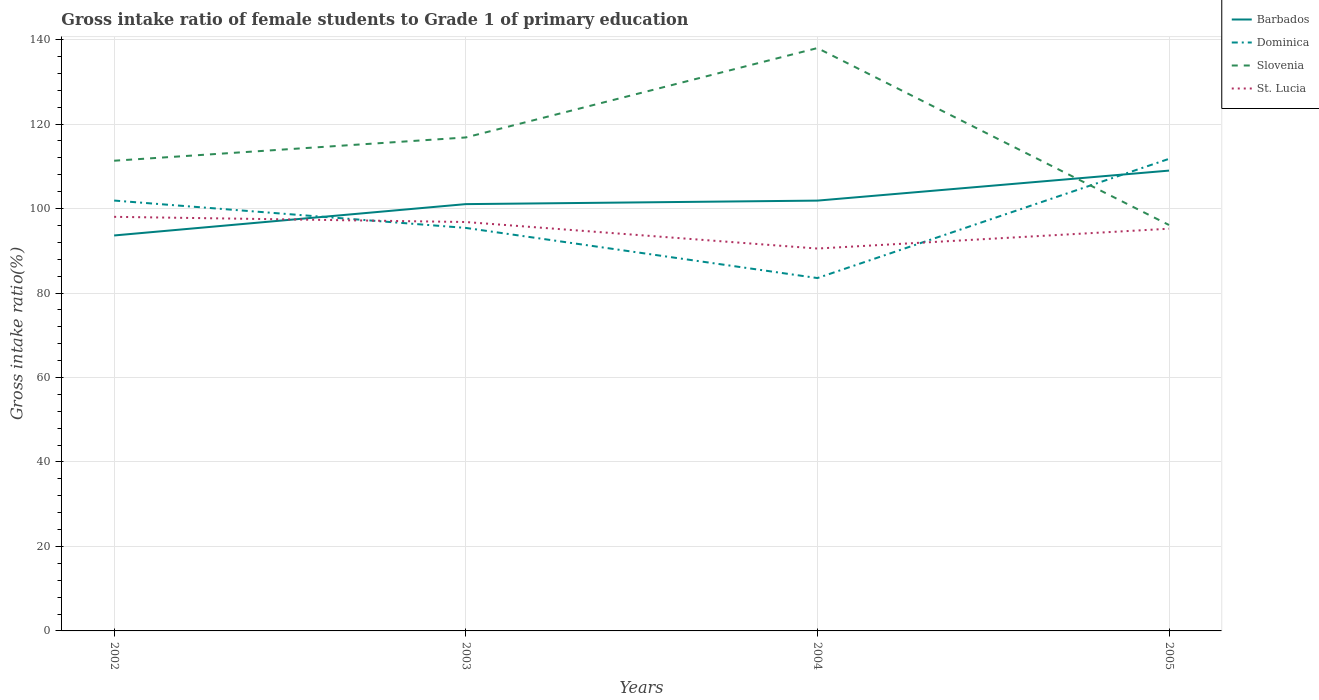How many different coloured lines are there?
Offer a terse response. 4. Does the line corresponding to Dominica intersect with the line corresponding to Slovenia?
Your response must be concise. Yes. Across all years, what is the maximum gross intake ratio in Dominica?
Offer a very short reply. 83.55. What is the total gross intake ratio in Slovenia in the graph?
Ensure brevity in your answer.  -5.51. What is the difference between the highest and the second highest gross intake ratio in Barbados?
Provide a succinct answer. 15.36. What is the difference between the highest and the lowest gross intake ratio in Slovenia?
Make the answer very short. 2. How many lines are there?
Offer a very short reply. 4. What is the difference between two consecutive major ticks on the Y-axis?
Give a very brief answer. 20. Are the values on the major ticks of Y-axis written in scientific E-notation?
Your response must be concise. No. Does the graph contain any zero values?
Keep it short and to the point. No. Does the graph contain grids?
Keep it short and to the point. Yes. What is the title of the graph?
Your answer should be compact. Gross intake ratio of female students to Grade 1 of primary education. What is the label or title of the X-axis?
Offer a terse response. Years. What is the label or title of the Y-axis?
Your response must be concise. Gross intake ratio(%). What is the Gross intake ratio(%) of Barbados in 2002?
Offer a very short reply. 93.63. What is the Gross intake ratio(%) of Dominica in 2002?
Provide a short and direct response. 101.9. What is the Gross intake ratio(%) of Slovenia in 2002?
Make the answer very short. 111.33. What is the Gross intake ratio(%) of St. Lucia in 2002?
Offer a very short reply. 98.05. What is the Gross intake ratio(%) of Barbados in 2003?
Your response must be concise. 101.05. What is the Gross intake ratio(%) of Dominica in 2003?
Offer a very short reply. 95.42. What is the Gross intake ratio(%) of Slovenia in 2003?
Offer a terse response. 116.84. What is the Gross intake ratio(%) of St. Lucia in 2003?
Give a very brief answer. 96.81. What is the Gross intake ratio(%) in Barbados in 2004?
Offer a terse response. 101.88. What is the Gross intake ratio(%) of Dominica in 2004?
Offer a terse response. 83.55. What is the Gross intake ratio(%) in Slovenia in 2004?
Your answer should be compact. 138. What is the Gross intake ratio(%) of St. Lucia in 2004?
Provide a short and direct response. 90.54. What is the Gross intake ratio(%) of Barbados in 2005?
Offer a very short reply. 108.99. What is the Gross intake ratio(%) of Dominica in 2005?
Offer a very short reply. 111.77. What is the Gross intake ratio(%) in Slovenia in 2005?
Offer a terse response. 96.11. What is the Gross intake ratio(%) of St. Lucia in 2005?
Make the answer very short. 95.23. Across all years, what is the maximum Gross intake ratio(%) of Barbados?
Ensure brevity in your answer.  108.99. Across all years, what is the maximum Gross intake ratio(%) of Dominica?
Provide a short and direct response. 111.77. Across all years, what is the maximum Gross intake ratio(%) of Slovenia?
Your answer should be very brief. 138. Across all years, what is the maximum Gross intake ratio(%) in St. Lucia?
Provide a succinct answer. 98.05. Across all years, what is the minimum Gross intake ratio(%) in Barbados?
Provide a succinct answer. 93.63. Across all years, what is the minimum Gross intake ratio(%) of Dominica?
Provide a succinct answer. 83.55. Across all years, what is the minimum Gross intake ratio(%) in Slovenia?
Provide a short and direct response. 96.11. Across all years, what is the minimum Gross intake ratio(%) of St. Lucia?
Provide a succinct answer. 90.54. What is the total Gross intake ratio(%) in Barbados in the graph?
Provide a succinct answer. 405.56. What is the total Gross intake ratio(%) of Dominica in the graph?
Provide a short and direct response. 392.64. What is the total Gross intake ratio(%) of Slovenia in the graph?
Provide a succinct answer. 462.28. What is the total Gross intake ratio(%) of St. Lucia in the graph?
Your response must be concise. 380.63. What is the difference between the Gross intake ratio(%) of Barbados in 2002 and that in 2003?
Make the answer very short. -7.42. What is the difference between the Gross intake ratio(%) of Dominica in 2002 and that in 2003?
Your response must be concise. 6.48. What is the difference between the Gross intake ratio(%) of Slovenia in 2002 and that in 2003?
Give a very brief answer. -5.51. What is the difference between the Gross intake ratio(%) in St. Lucia in 2002 and that in 2003?
Provide a succinct answer. 1.23. What is the difference between the Gross intake ratio(%) in Barbados in 2002 and that in 2004?
Provide a short and direct response. -8.25. What is the difference between the Gross intake ratio(%) of Dominica in 2002 and that in 2004?
Provide a succinct answer. 18.35. What is the difference between the Gross intake ratio(%) of Slovenia in 2002 and that in 2004?
Provide a short and direct response. -26.67. What is the difference between the Gross intake ratio(%) in St. Lucia in 2002 and that in 2004?
Your answer should be very brief. 7.51. What is the difference between the Gross intake ratio(%) in Barbados in 2002 and that in 2005?
Make the answer very short. -15.36. What is the difference between the Gross intake ratio(%) of Dominica in 2002 and that in 2005?
Your answer should be very brief. -9.88. What is the difference between the Gross intake ratio(%) in Slovenia in 2002 and that in 2005?
Make the answer very short. 15.22. What is the difference between the Gross intake ratio(%) in St. Lucia in 2002 and that in 2005?
Offer a terse response. 2.81. What is the difference between the Gross intake ratio(%) of Barbados in 2003 and that in 2004?
Make the answer very short. -0.83. What is the difference between the Gross intake ratio(%) in Dominica in 2003 and that in 2004?
Provide a succinct answer. 11.87. What is the difference between the Gross intake ratio(%) in Slovenia in 2003 and that in 2004?
Provide a succinct answer. -21.16. What is the difference between the Gross intake ratio(%) in St. Lucia in 2003 and that in 2004?
Your answer should be compact. 6.28. What is the difference between the Gross intake ratio(%) in Barbados in 2003 and that in 2005?
Your answer should be compact. -7.94. What is the difference between the Gross intake ratio(%) in Dominica in 2003 and that in 2005?
Your answer should be compact. -16.35. What is the difference between the Gross intake ratio(%) in Slovenia in 2003 and that in 2005?
Ensure brevity in your answer.  20.73. What is the difference between the Gross intake ratio(%) of St. Lucia in 2003 and that in 2005?
Provide a short and direct response. 1.58. What is the difference between the Gross intake ratio(%) in Barbados in 2004 and that in 2005?
Your answer should be very brief. -7.11. What is the difference between the Gross intake ratio(%) of Dominica in 2004 and that in 2005?
Your answer should be compact. -28.23. What is the difference between the Gross intake ratio(%) in Slovenia in 2004 and that in 2005?
Offer a terse response. 41.89. What is the difference between the Gross intake ratio(%) in St. Lucia in 2004 and that in 2005?
Keep it short and to the point. -4.69. What is the difference between the Gross intake ratio(%) of Barbados in 2002 and the Gross intake ratio(%) of Dominica in 2003?
Your answer should be very brief. -1.79. What is the difference between the Gross intake ratio(%) in Barbados in 2002 and the Gross intake ratio(%) in Slovenia in 2003?
Offer a very short reply. -23.21. What is the difference between the Gross intake ratio(%) in Barbados in 2002 and the Gross intake ratio(%) in St. Lucia in 2003?
Offer a very short reply. -3.18. What is the difference between the Gross intake ratio(%) of Dominica in 2002 and the Gross intake ratio(%) of Slovenia in 2003?
Make the answer very short. -14.94. What is the difference between the Gross intake ratio(%) of Dominica in 2002 and the Gross intake ratio(%) of St. Lucia in 2003?
Your answer should be compact. 5.08. What is the difference between the Gross intake ratio(%) of Slovenia in 2002 and the Gross intake ratio(%) of St. Lucia in 2003?
Provide a short and direct response. 14.51. What is the difference between the Gross intake ratio(%) in Barbados in 2002 and the Gross intake ratio(%) in Dominica in 2004?
Your response must be concise. 10.08. What is the difference between the Gross intake ratio(%) in Barbados in 2002 and the Gross intake ratio(%) in Slovenia in 2004?
Provide a short and direct response. -44.37. What is the difference between the Gross intake ratio(%) in Barbados in 2002 and the Gross intake ratio(%) in St. Lucia in 2004?
Provide a succinct answer. 3.09. What is the difference between the Gross intake ratio(%) of Dominica in 2002 and the Gross intake ratio(%) of Slovenia in 2004?
Your answer should be very brief. -36.1. What is the difference between the Gross intake ratio(%) of Dominica in 2002 and the Gross intake ratio(%) of St. Lucia in 2004?
Provide a short and direct response. 11.36. What is the difference between the Gross intake ratio(%) of Slovenia in 2002 and the Gross intake ratio(%) of St. Lucia in 2004?
Your answer should be compact. 20.79. What is the difference between the Gross intake ratio(%) in Barbados in 2002 and the Gross intake ratio(%) in Dominica in 2005?
Offer a terse response. -18.14. What is the difference between the Gross intake ratio(%) of Barbados in 2002 and the Gross intake ratio(%) of Slovenia in 2005?
Give a very brief answer. -2.48. What is the difference between the Gross intake ratio(%) of Barbados in 2002 and the Gross intake ratio(%) of St. Lucia in 2005?
Ensure brevity in your answer.  -1.6. What is the difference between the Gross intake ratio(%) of Dominica in 2002 and the Gross intake ratio(%) of Slovenia in 2005?
Keep it short and to the point. 5.79. What is the difference between the Gross intake ratio(%) in Dominica in 2002 and the Gross intake ratio(%) in St. Lucia in 2005?
Make the answer very short. 6.67. What is the difference between the Gross intake ratio(%) in Slovenia in 2002 and the Gross intake ratio(%) in St. Lucia in 2005?
Offer a very short reply. 16.1. What is the difference between the Gross intake ratio(%) of Barbados in 2003 and the Gross intake ratio(%) of Dominica in 2004?
Offer a very short reply. 17.51. What is the difference between the Gross intake ratio(%) in Barbados in 2003 and the Gross intake ratio(%) in Slovenia in 2004?
Your answer should be compact. -36.95. What is the difference between the Gross intake ratio(%) in Barbados in 2003 and the Gross intake ratio(%) in St. Lucia in 2004?
Your response must be concise. 10.52. What is the difference between the Gross intake ratio(%) in Dominica in 2003 and the Gross intake ratio(%) in Slovenia in 2004?
Your answer should be very brief. -42.58. What is the difference between the Gross intake ratio(%) in Dominica in 2003 and the Gross intake ratio(%) in St. Lucia in 2004?
Your answer should be compact. 4.88. What is the difference between the Gross intake ratio(%) of Slovenia in 2003 and the Gross intake ratio(%) of St. Lucia in 2004?
Make the answer very short. 26.3. What is the difference between the Gross intake ratio(%) in Barbados in 2003 and the Gross intake ratio(%) in Dominica in 2005?
Offer a terse response. -10.72. What is the difference between the Gross intake ratio(%) of Barbados in 2003 and the Gross intake ratio(%) of Slovenia in 2005?
Make the answer very short. 4.94. What is the difference between the Gross intake ratio(%) of Barbados in 2003 and the Gross intake ratio(%) of St. Lucia in 2005?
Give a very brief answer. 5.82. What is the difference between the Gross intake ratio(%) of Dominica in 2003 and the Gross intake ratio(%) of Slovenia in 2005?
Your answer should be compact. -0.69. What is the difference between the Gross intake ratio(%) in Dominica in 2003 and the Gross intake ratio(%) in St. Lucia in 2005?
Keep it short and to the point. 0.19. What is the difference between the Gross intake ratio(%) of Slovenia in 2003 and the Gross intake ratio(%) of St. Lucia in 2005?
Offer a very short reply. 21.61. What is the difference between the Gross intake ratio(%) of Barbados in 2004 and the Gross intake ratio(%) of Dominica in 2005?
Offer a very short reply. -9.89. What is the difference between the Gross intake ratio(%) of Barbados in 2004 and the Gross intake ratio(%) of Slovenia in 2005?
Provide a short and direct response. 5.77. What is the difference between the Gross intake ratio(%) in Barbados in 2004 and the Gross intake ratio(%) in St. Lucia in 2005?
Your answer should be very brief. 6.65. What is the difference between the Gross intake ratio(%) of Dominica in 2004 and the Gross intake ratio(%) of Slovenia in 2005?
Your answer should be very brief. -12.56. What is the difference between the Gross intake ratio(%) of Dominica in 2004 and the Gross intake ratio(%) of St. Lucia in 2005?
Your response must be concise. -11.68. What is the difference between the Gross intake ratio(%) in Slovenia in 2004 and the Gross intake ratio(%) in St. Lucia in 2005?
Offer a very short reply. 42.77. What is the average Gross intake ratio(%) of Barbados per year?
Your response must be concise. 101.39. What is the average Gross intake ratio(%) in Dominica per year?
Your response must be concise. 98.16. What is the average Gross intake ratio(%) of Slovenia per year?
Give a very brief answer. 115.57. What is the average Gross intake ratio(%) of St. Lucia per year?
Your answer should be very brief. 95.16. In the year 2002, what is the difference between the Gross intake ratio(%) in Barbados and Gross intake ratio(%) in Dominica?
Give a very brief answer. -8.27. In the year 2002, what is the difference between the Gross intake ratio(%) of Barbados and Gross intake ratio(%) of Slovenia?
Your response must be concise. -17.7. In the year 2002, what is the difference between the Gross intake ratio(%) of Barbados and Gross intake ratio(%) of St. Lucia?
Provide a short and direct response. -4.41. In the year 2002, what is the difference between the Gross intake ratio(%) of Dominica and Gross intake ratio(%) of Slovenia?
Offer a terse response. -9.43. In the year 2002, what is the difference between the Gross intake ratio(%) in Dominica and Gross intake ratio(%) in St. Lucia?
Offer a very short reply. 3.85. In the year 2002, what is the difference between the Gross intake ratio(%) of Slovenia and Gross intake ratio(%) of St. Lucia?
Provide a succinct answer. 13.28. In the year 2003, what is the difference between the Gross intake ratio(%) of Barbados and Gross intake ratio(%) of Dominica?
Ensure brevity in your answer.  5.63. In the year 2003, what is the difference between the Gross intake ratio(%) of Barbados and Gross intake ratio(%) of Slovenia?
Keep it short and to the point. -15.78. In the year 2003, what is the difference between the Gross intake ratio(%) in Barbados and Gross intake ratio(%) in St. Lucia?
Ensure brevity in your answer.  4.24. In the year 2003, what is the difference between the Gross intake ratio(%) in Dominica and Gross intake ratio(%) in Slovenia?
Your answer should be compact. -21.42. In the year 2003, what is the difference between the Gross intake ratio(%) of Dominica and Gross intake ratio(%) of St. Lucia?
Your answer should be compact. -1.39. In the year 2003, what is the difference between the Gross intake ratio(%) in Slovenia and Gross intake ratio(%) in St. Lucia?
Make the answer very short. 20.02. In the year 2004, what is the difference between the Gross intake ratio(%) of Barbados and Gross intake ratio(%) of Dominica?
Give a very brief answer. 18.34. In the year 2004, what is the difference between the Gross intake ratio(%) in Barbados and Gross intake ratio(%) in Slovenia?
Keep it short and to the point. -36.12. In the year 2004, what is the difference between the Gross intake ratio(%) in Barbados and Gross intake ratio(%) in St. Lucia?
Provide a short and direct response. 11.35. In the year 2004, what is the difference between the Gross intake ratio(%) of Dominica and Gross intake ratio(%) of Slovenia?
Provide a succinct answer. -54.45. In the year 2004, what is the difference between the Gross intake ratio(%) in Dominica and Gross intake ratio(%) in St. Lucia?
Your answer should be compact. -6.99. In the year 2004, what is the difference between the Gross intake ratio(%) in Slovenia and Gross intake ratio(%) in St. Lucia?
Give a very brief answer. 47.46. In the year 2005, what is the difference between the Gross intake ratio(%) of Barbados and Gross intake ratio(%) of Dominica?
Offer a terse response. -2.78. In the year 2005, what is the difference between the Gross intake ratio(%) of Barbados and Gross intake ratio(%) of Slovenia?
Provide a short and direct response. 12.88. In the year 2005, what is the difference between the Gross intake ratio(%) in Barbados and Gross intake ratio(%) in St. Lucia?
Your answer should be very brief. 13.76. In the year 2005, what is the difference between the Gross intake ratio(%) in Dominica and Gross intake ratio(%) in Slovenia?
Offer a terse response. 15.67. In the year 2005, what is the difference between the Gross intake ratio(%) in Dominica and Gross intake ratio(%) in St. Lucia?
Keep it short and to the point. 16.54. In the year 2005, what is the difference between the Gross intake ratio(%) of Slovenia and Gross intake ratio(%) of St. Lucia?
Ensure brevity in your answer.  0.88. What is the ratio of the Gross intake ratio(%) in Barbados in 2002 to that in 2003?
Your response must be concise. 0.93. What is the ratio of the Gross intake ratio(%) of Dominica in 2002 to that in 2003?
Your response must be concise. 1.07. What is the ratio of the Gross intake ratio(%) in Slovenia in 2002 to that in 2003?
Keep it short and to the point. 0.95. What is the ratio of the Gross intake ratio(%) in St. Lucia in 2002 to that in 2003?
Your answer should be very brief. 1.01. What is the ratio of the Gross intake ratio(%) in Barbados in 2002 to that in 2004?
Offer a terse response. 0.92. What is the ratio of the Gross intake ratio(%) of Dominica in 2002 to that in 2004?
Provide a short and direct response. 1.22. What is the ratio of the Gross intake ratio(%) of Slovenia in 2002 to that in 2004?
Make the answer very short. 0.81. What is the ratio of the Gross intake ratio(%) of St. Lucia in 2002 to that in 2004?
Ensure brevity in your answer.  1.08. What is the ratio of the Gross intake ratio(%) in Barbados in 2002 to that in 2005?
Give a very brief answer. 0.86. What is the ratio of the Gross intake ratio(%) of Dominica in 2002 to that in 2005?
Keep it short and to the point. 0.91. What is the ratio of the Gross intake ratio(%) in Slovenia in 2002 to that in 2005?
Give a very brief answer. 1.16. What is the ratio of the Gross intake ratio(%) in St. Lucia in 2002 to that in 2005?
Your answer should be compact. 1.03. What is the ratio of the Gross intake ratio(%) of Dominica in 2003 to that in 2004?
Ensure brevity in your answer.  1.14. What is the ratio of the Gross intake ratio(%) of Slovenia in 2003 to that in 2004?
Keep it short and to the point. 0.85. What is the ratio of the Gross intake ratio(%) in St. Lucia in 2003 to that in 2004?
Offer a very short reply. 1.07. What is the ratio of the Gross intake ratio(%) in Barbados in 2003 to that in 2005?
Give a very brief answer. 0.93. What is the ratio of the Gross intake ratio(%) of Dominica in 2003 to that in 2005?
Ensure brevity in your answer.  0.85. What is the ratio of the Gross intake ratio(%) in Slovenia in 2003 to that in 2005?
Provide a short and direct response. 1.22. What is the ratio of the Gross intake ratio(%) in St. Lucia in 2003 to that in 2005?
Keep it short and to the point. 1.02. What is the ratio of the Gross intake ratio(%) of Barbados in 2004 to that in 2005?
Provide a short and direct response. 0.93. What is the ratio of the Gross intake ratio(%) of Dominica in 2004 to that in 2005?
Your answer should be very brief. 0.75. What is the ratio of the Gross intake ratio(%) of Slovenia in 2004 to that in 2005?
Make the answer very short. 1.44. What is the ratio of the Gross intake ratio(%) of St. Lucia in 2004 to that in 2005?
Ensure brevity in your answer.  0.95. What is the difference between the highest and the second highest Gross intake ratio(%) in Barbados?
Your response must be concise. 7.11. What is the difference between the highest and the second highest Gross intake ratio(%) in Dominica?
Provide a short and direct response. 9.88. What is the difference between the highest and the second highest Gross intake ratio(%) in Slovenia?
Offer a terse response. 21.16. What is the difference between the highest and the second highest Gross intake ratio(%) of St. Lucia?
Ensure brevity in your answer.  1.23. What is the difference between the highest and the lowest Gross intake ratio(%) in Barbados?
Keep it short and to the point. 15.36. What is the difference between the highest and the lowest Gross intake ratio(%) of Dominica?
Your answer should be very brief. 28.23. What is the difference between the highest and the lowest Gross intake ratio(%) in Slovenia?
Keep it short and to the point. 41.89. What is the difference between the highest and the lowest Gross intake ratio(%) of St. Lucia?
Give a very brief answer. 7.51. 